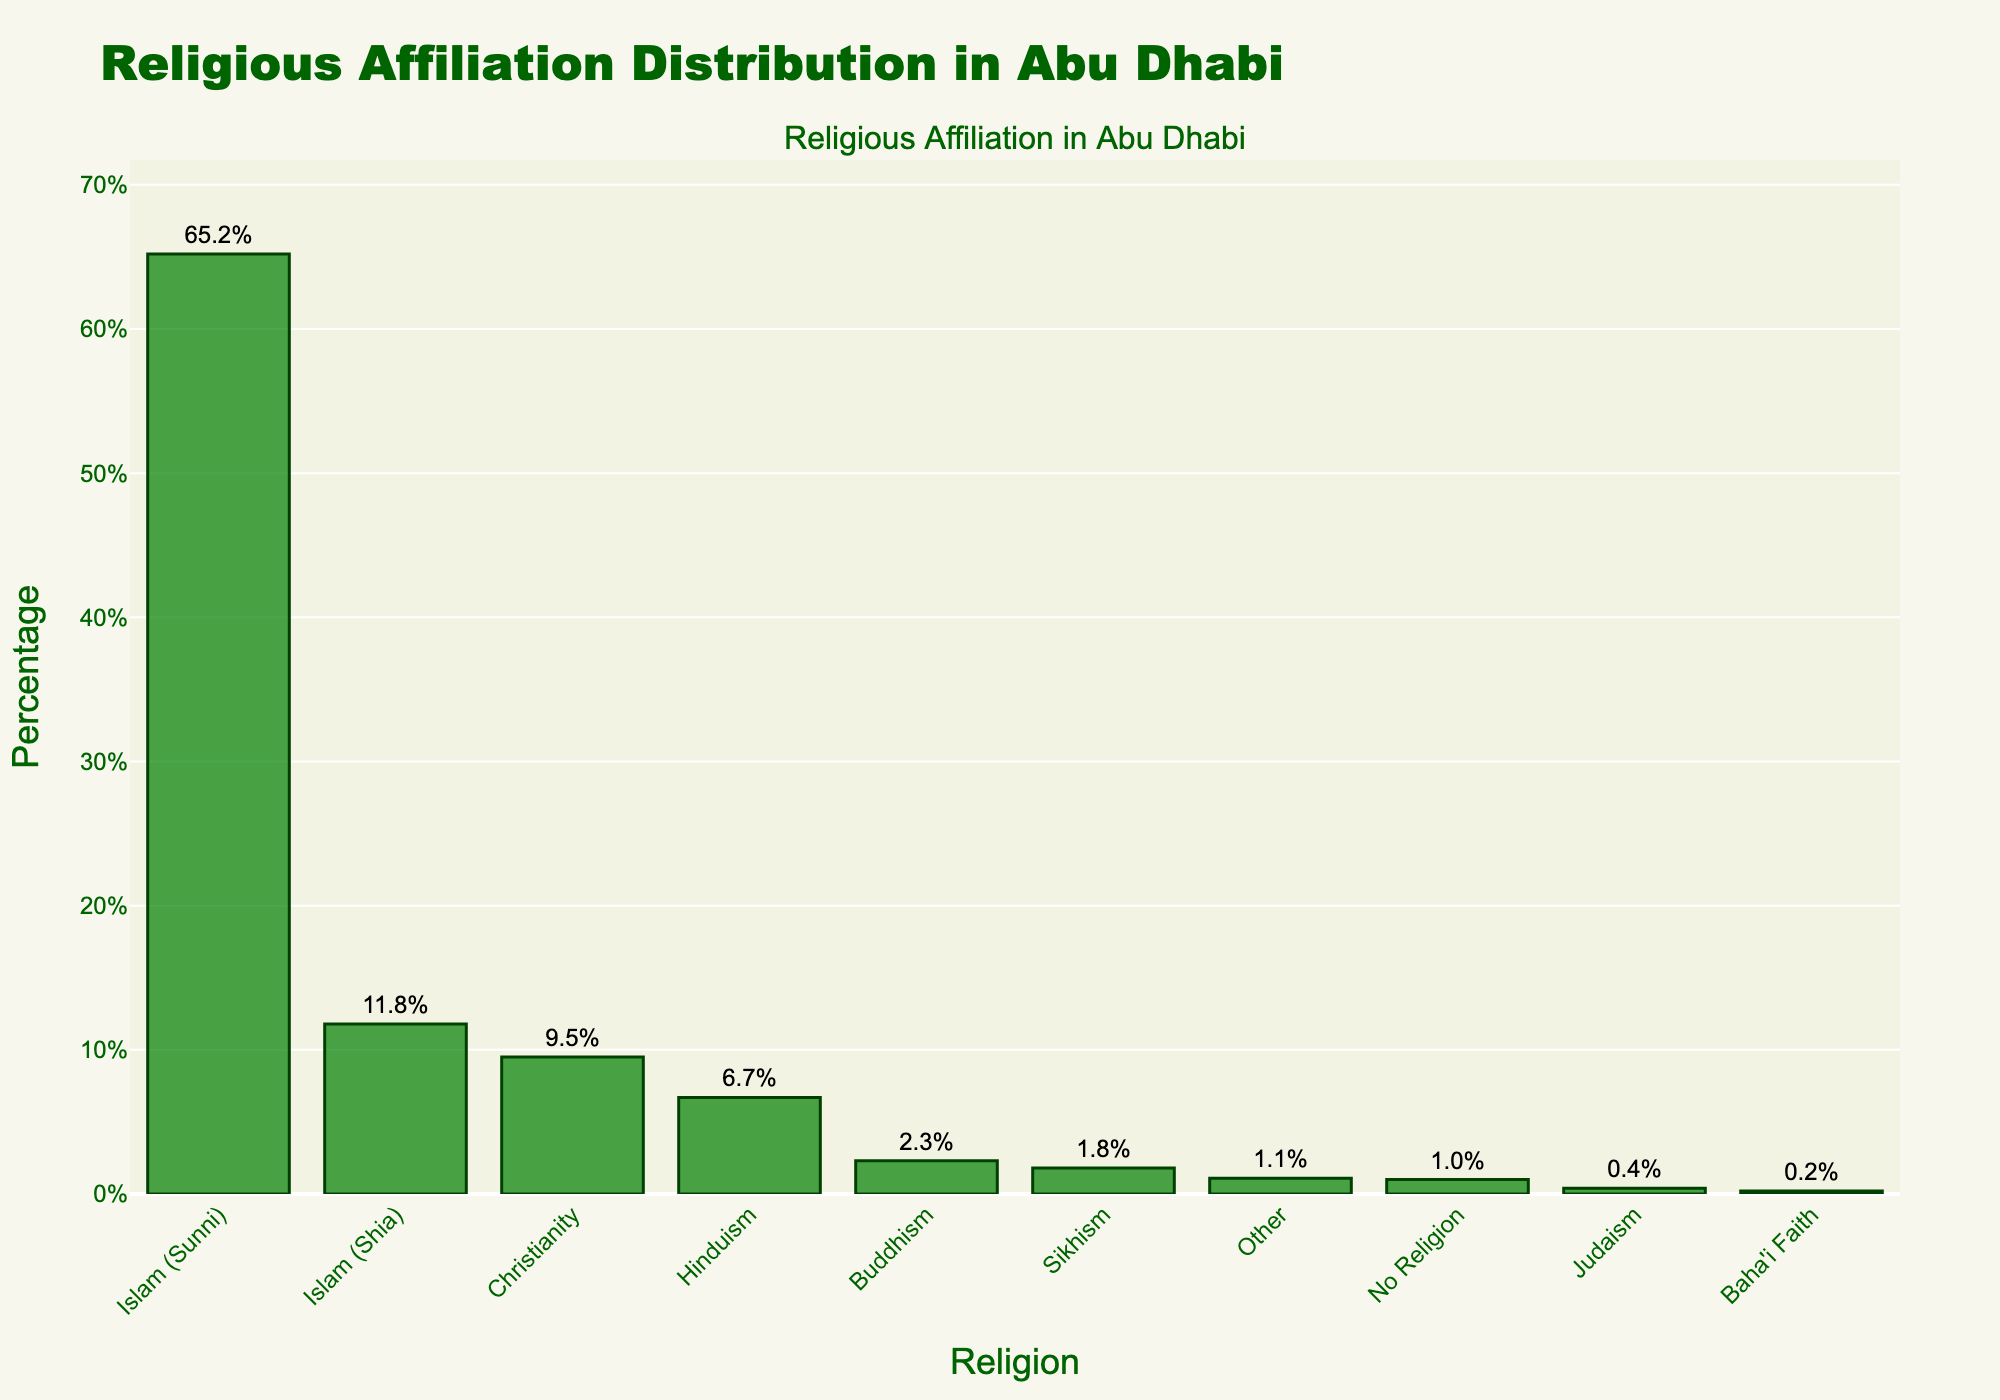What is the most prevalent religious affiliation in Abu Dhabi? The Sunni Islam bar is the highest, indicating that it has the largest percentage. According to the chart, Sunni Islam has a percentage of 65.2%.
Answer: Sunni Islam (65.2%) What is the difference in percentage between Sunni Islam and Shia Islam? Sunni Islam has a percentage of 65.2%, while Shia Islam has 11.8%. Subtracting these two values gives us 65.2 - 11.8 = 53.4%.
Answer: 53.4% Which is more prevalent in Abu Dhabi, Christianity or Hinduism? By comparing the heights of the bars, we observe that Christianity (9.5%) is higher than Hinduism (6.7%).
Answer: Christianity (9.5%) What is the combined percentage of the non-major religions (Judaism, Baha'i Faith, Other, and No Religion)? Adding the percentages: Judaism (0.4%) + Baha'i Faith (0.2%) + Other (1.1%) + No Religion (1.0%) = 0.4 + 0.2 + 1.1 + 1.0 = 2.7%.
Answer: 2.7% Which religious group is represented by the smallest bar? The bar for the Baha'i Faith is the smallest, indicating it has the lowest percentage at 0.2%.
Answer: Baha'i Faith (0.2%) What is the percentage of all Islamic affiliations combined? Adding the percentages of Sunni Islam (65.2%) and Shia Islam (11.8%): 65.2 + 11.8 = 77.0%.
Answer: 77.0% Is the percentage of Buddhist followers higher or lower than the percentage of Sikhs? Comparing the bars: Buddhism is 2.3% and Sikhism is 1.8%. Thus, Buddhism is higher.
Answer: Higher (2.3% vs 1.8%) What is the average percentage of the top three religious affiliations? The top three religious affiliations are Sunni Islam (65.2%), Shia Islam (11.8%), and Christianity (9.5%). The average is (65.2 + 11.8 + 9.5) / 3 = 86.5 / 3 = 28.83%.
Answer: 28.83% What is the range of the percentages for all listed religious affiliations? The highest percentage is Sunni Islam (65.2%) and the lowest is Baha'i Faith (0.2%). The range is 65.2 - 0.2 = 65.0%.
Answer: 65.0% 